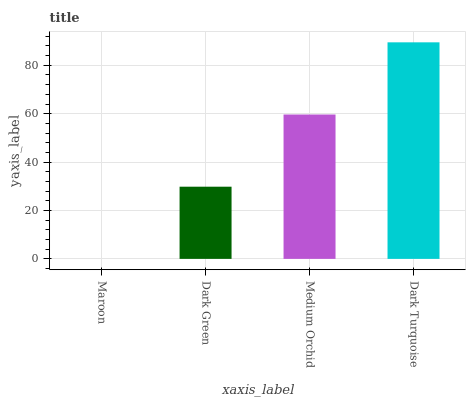Is Maroon the minimum?
Answer yes or no. Yes. Is Dark Turquoise the maximum?
Answer yes or no. Yes. Is Dark Green the minimum?
Answer yes or no. No. Is Dark Green the maximum?
Answer yes or no. No. Is Dark Green greater than Maroon?
Answer yes or no. Yes. Is Maroon less than Dark Green?
Answer yes or no. Yes. Is Maroon greater than Dark Green?
Answer yes or no. No. Is Dark Green less than Maroon?
Answer yes or no. No. Is Medium Orchid the high median?
Answer yes or no. Yes. Is Dark Green the low median?
Answer yes or no. Yes. Is Maroon the high median?
Answer yes or no. No. Is Dark Turquoise the low median?
Answer yes or no. No. 